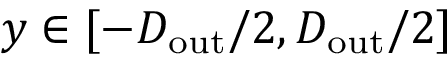Convert formula to latex. <formula><loc_0><loc_0><loc_500><loc_500>y \in [ - D _ { o u t } / 2 , D _ { o u t } / 2 ]</formula> 